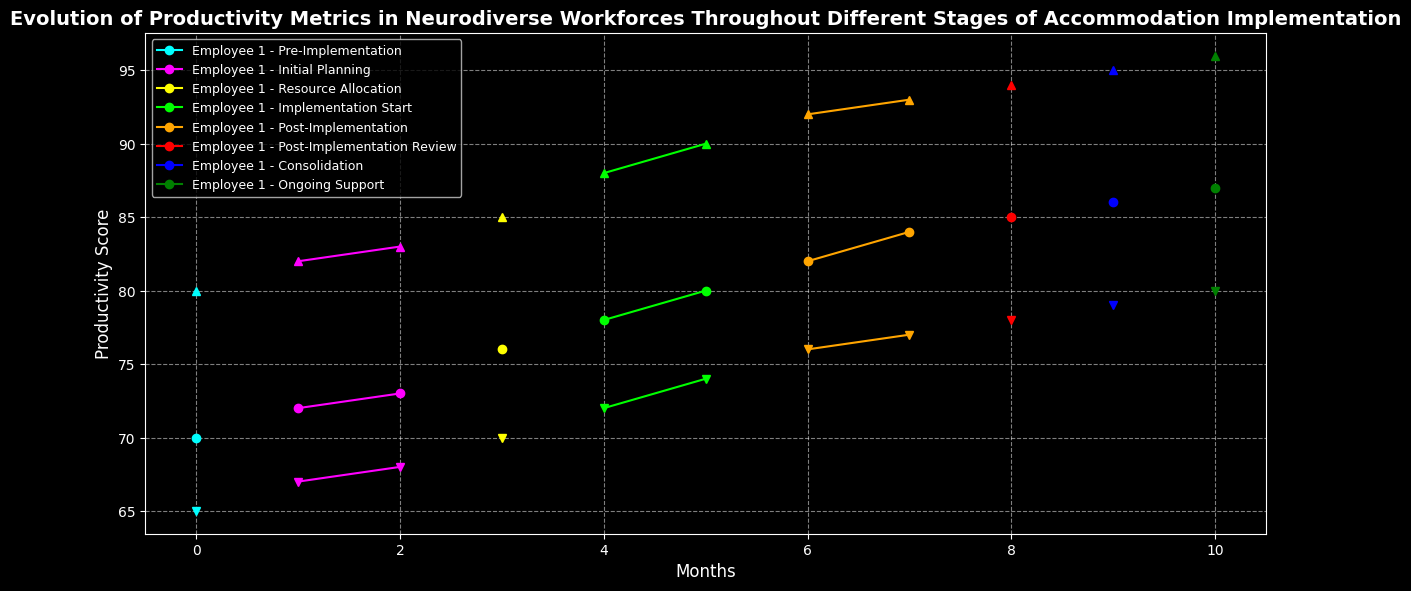Which stage has the highest average productivity score for Employee 3? Average the productivity scores of Employee 3 across all stages and compare them. In the "Ongoing Support" stage, Employee 3 has the average score of 96 which is the highest.
Answer: Ongoing Support What is the difference in productivity scores for Employee 2 between the Pre-Implementation and Post-Implementation stages? Look at the productivity scores of Employee 2 in the Pre-Implementation stage (65) and Post-Implementation stage (76). Compute the difference: 76 - 65 = 11.
Answer: 11 In which stage did Employee 1 see a significant increase in productivity score? Compare Employee 1's productivity scores across all stages and identify where the jump is the most significant. There's a noticeable increase during the "Resource Allocation" stage from 73 to 76.
Answer: Resource Allocation How does the productivity score trend differ between Employee 2 and Employee 3 throughout the stages? Observe the line representing Employee 2 and compare its shape and direction with the line of Employee 3. Employee 3 consistently shows an upward trend, while Employee 2 has a steadier but less pronounced increase.
Answer: Employee 3 shows a steeper upward trend What is the average productivity score for Employee 1 during the Implementation Start stage? Identify the productivity scores for Employee 1 in the Implementation Start stage (78 and 80), and compute the average: (78 + 80) / 2 = 79.
Answer: 79 Which stage shows the largest variance in productivity scores among all employees? Determine the variance by computing the difference between the highest and lowest productivity scores in each stage. The “Implementation Start” stage shows the largest variance (90 - 72 = 18).
Answer: Implementation Start During which stage did productivity score for Employee 2 show the smallest change? Examine the scores for Employee 2 across all stages and identify the stage with the smallest change. Between the "Pre-Implementation" and "Initial Planning" stages, the change is the smallest (67 - 65 = 2).
Answer: Initial Planning Which color represents the Consolidation stage in the plot? Identify the color coding for stages in the legend and find the corresponding color for the "Consolidation" stage. The Consolidation stage is represented by blue.
Answer: blue 